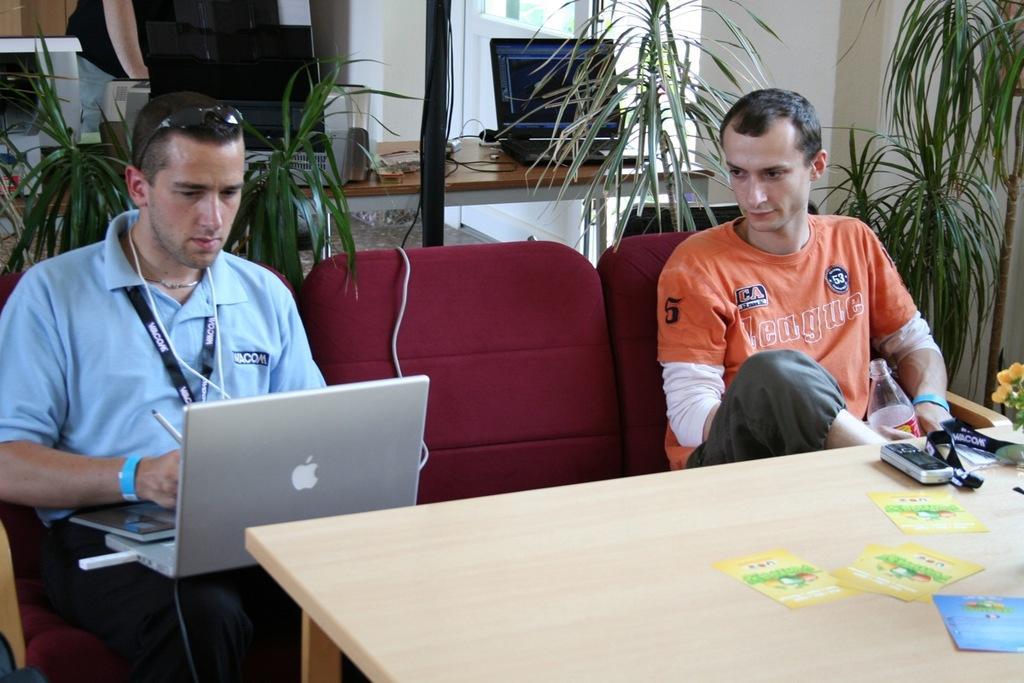Please provide a concise description of this image. This picture shows two men seated on the chairs and a man working on the laptop and we see few plants back of them and we see a table in front of them 